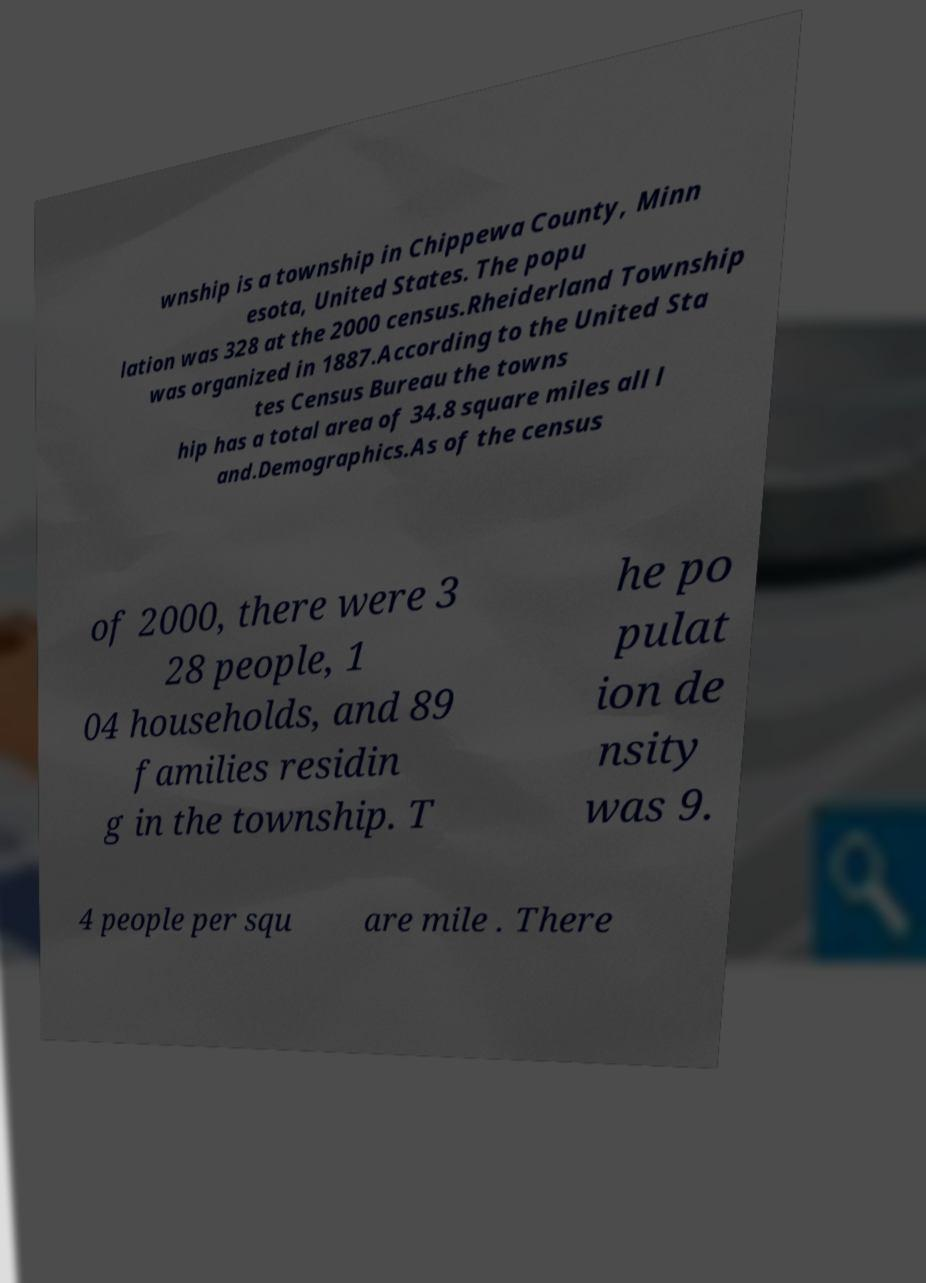Could you extract and type out the text from this image? wnship is a township in Chippewa County, Minn esota, United States. The popu lation was 328 at the 2000 census.Rheiderland Township was organized in 1887.According to the United Sta tes Census Bureau the towns hip has a total area of 34.8 square miles all l and.Demographics.As of the census of 2000, there were 3 28 people, 1 04 households, and 89 families residin g in the township. T he po pulat ion de nsity was 9. 4 people per squ are mile . There 